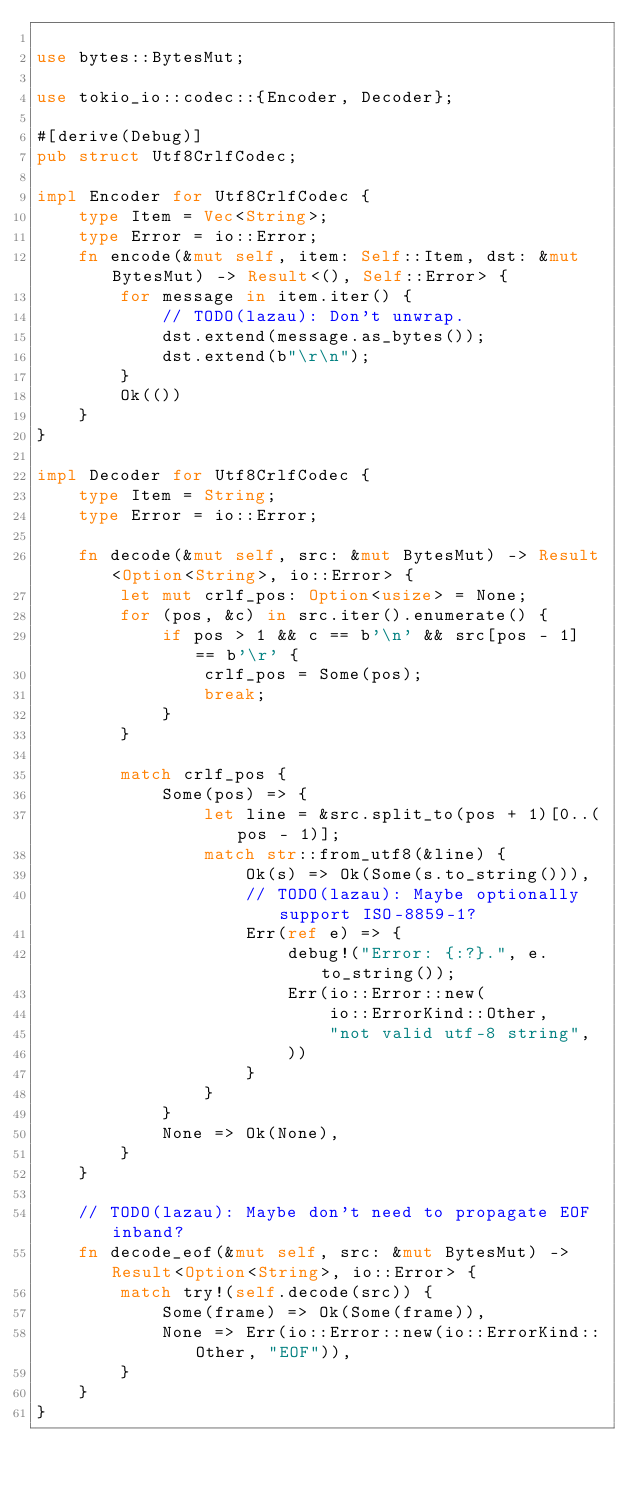<code> <loc_0><loc_0><loc_500><loc_500><_Rust_>
use bytes::BytesMut;

use tokio_io::codec::{Encoder, Decoder};

#[derive(Debug)]
pub struct Utf8CrlfCodec;

impl Encoder for Utf8CrlfCodec {
    type Item = Vec<String>;
    type Error = io::Error;
    fn encode(&mut self, item: Self::Item, dst: &mut BytesMut) -> Result<(), Self::Error> {
        for message in item.iter() {
            // TODO(lazau): Don't unwrap.
            dst.extend(message.as_bytes());
            dst.extend(b"\r\n");
        }
        Ok(())
    }
}

impl Decoder for Utf8CrlfCodec {
    type Item = String;
    type Error = io::Error;

    fn decode(&mut self, src: &mut BytesMut) -> Result<Option<String>, io::Error> {
        let mut crlf_pos: Option<usize> = None;
        for (pos, &c) in src.iter().enumerate() {
            if pos > 1 && c == b'\n' && src[pos - 1] == b'\r' {
                crlf_pos = Some(pos);
                break;
            }
        }

        match crlf_pos {
            Some(pos) => {
                let line = &src.split_to(pos + 1)[0..(pos - 1)];
                match str::from_utf8(&line) {
                    Ok(s) => Ok(Some(s.to_string())),
                    // TODO(lazau): Maybe optionally support ISO-8859-1?
                    Err(ref e) => {
                        debug!("Error: {:?}.", e.to_string());
                        Err(io::Error::new(
                            io::ErrorKind::Other,
                            "not valid utf-8 string",
                        ))
                    }
                }
            }
            None => Ok(None),
        }
    }

    // TODO(lazau): Maybe don't need to propagate EOF inband?
    fn decode_eof(&mut self, src: &mut BytesMut) -> Result<Option<String>, io::Error> {
        match try!(self.decode(src)) {
            Some(frame) => Ok(Some(frame)),
            None => Err(io::Error::new(io::ErrorKind::Other, "EOF")),
        }
    }
}
</code> 